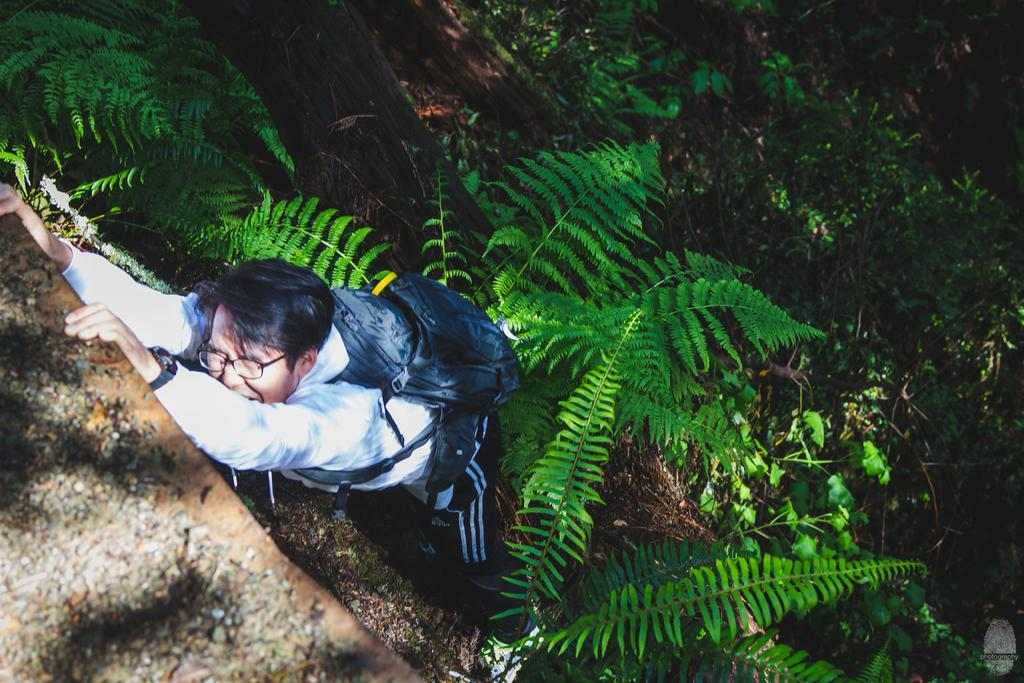Who is present in the image? There is a man in the picture. What is the man carrying in the image? The man is carrying a backpack. What can be seen in the background of the picture? There are trees in the background of the picture. Is there any additional information about the image itself? Yes, there is a watermark on the image. How many women are present in the image? There are no women present in the image; it features a man carrying a backpack. What type of roof is visible in the image? There is no roof visible in the image; it features a man carrying a backpack with trees in the background. 